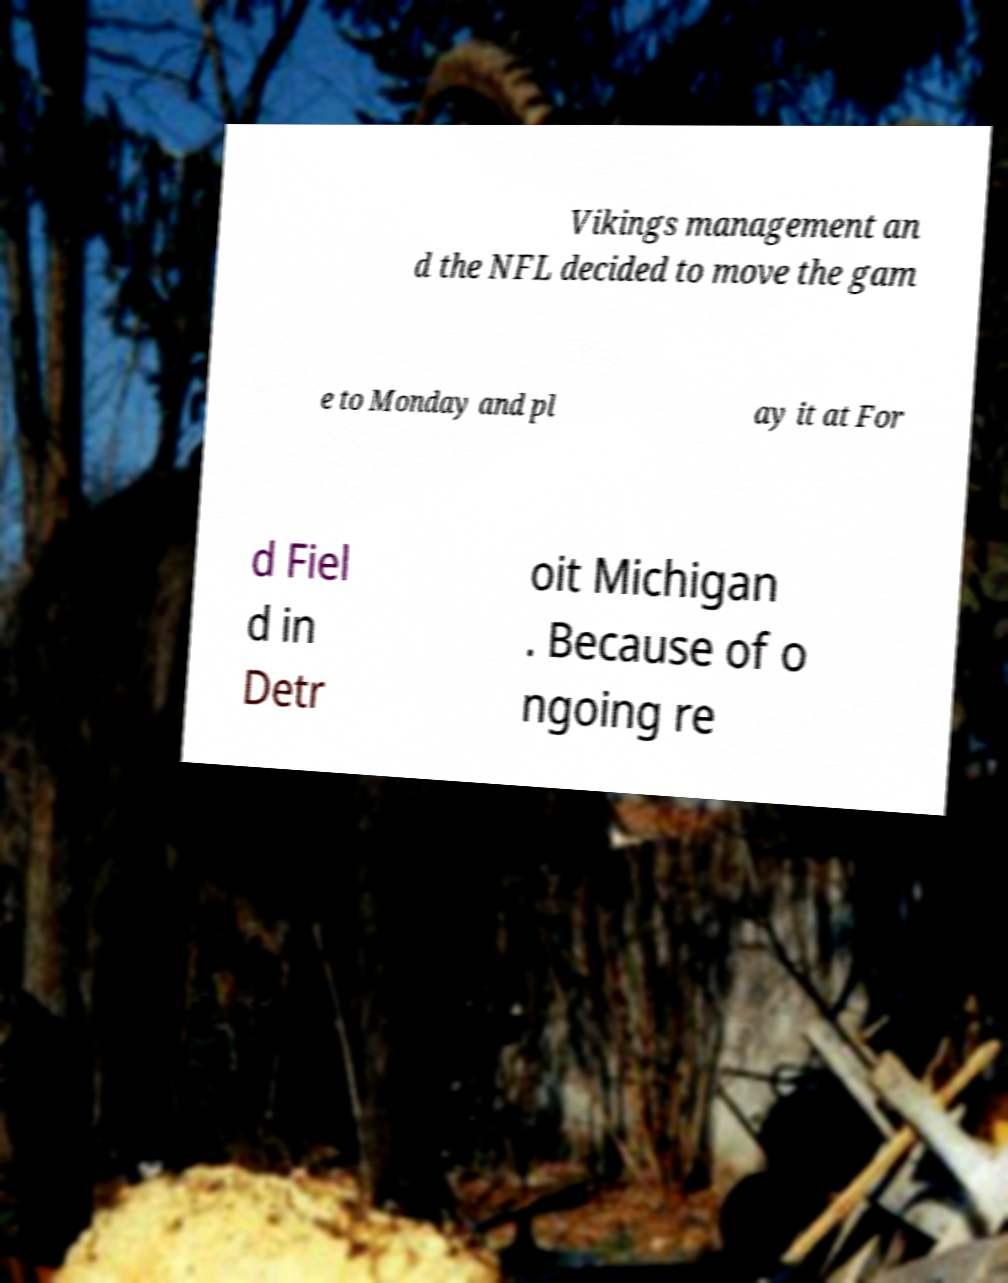Please identify and transcribe the text found in this image. Vikings management an d the NFL decided to move the gam e to Monday and pl ay it at For d Fiel d in Detr oit Michigan . Because of o ngoing re 